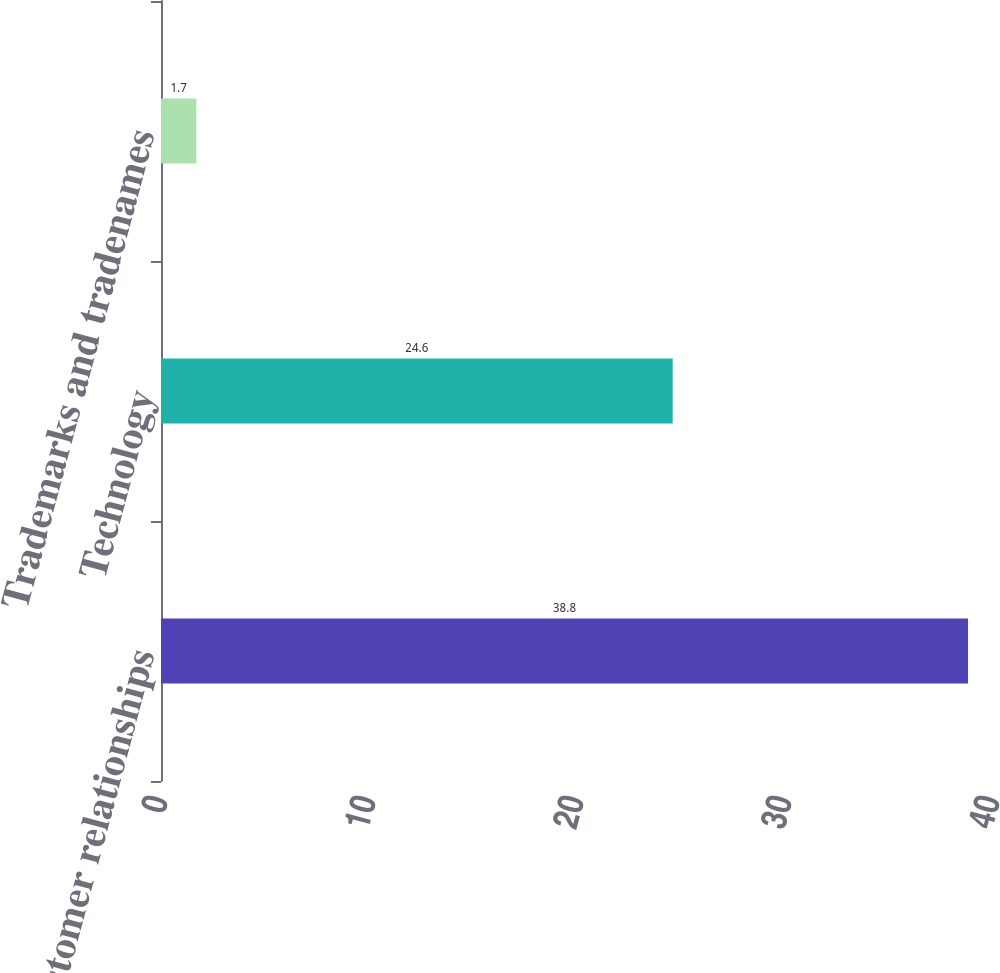Convert chart. <chart><loc_0><loc_0><loc_500><loc_500><bar_chart><fcel>Customer relationships<fcel>Technology<fcel>Trademarks and tradenames<nl><fcel>38.8<fcel>24.6<fcel>1.7<nl></chart> 